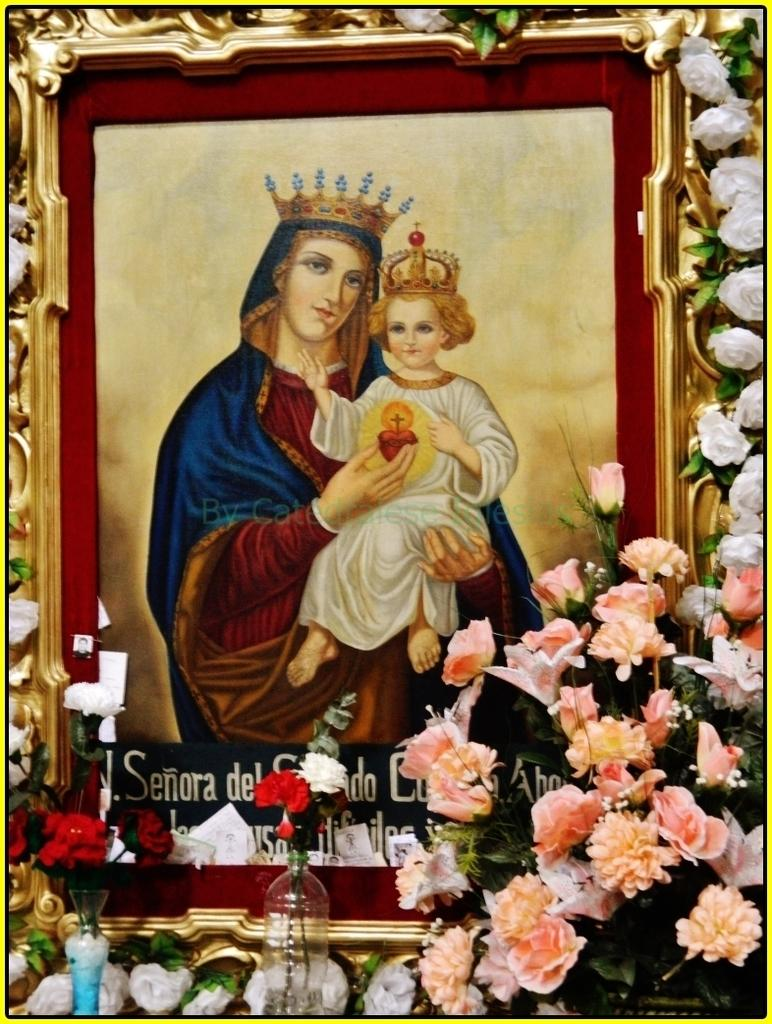What object can be seen in the image that typically holds a photograph? There is a photo frame in the image. What is written or printed at the bottom side of the frame? There is text at the bottom side of the frame. What type of natural elements are present in the image? There are flowers in the image. What else can be seen at the bottom side of the picture? There are objects at the bottom side of the picture. What type of hat is the person wearing in the image? There is no person wearing a hat in the image; it only features a photo frame, text, flowers, and other objects. 